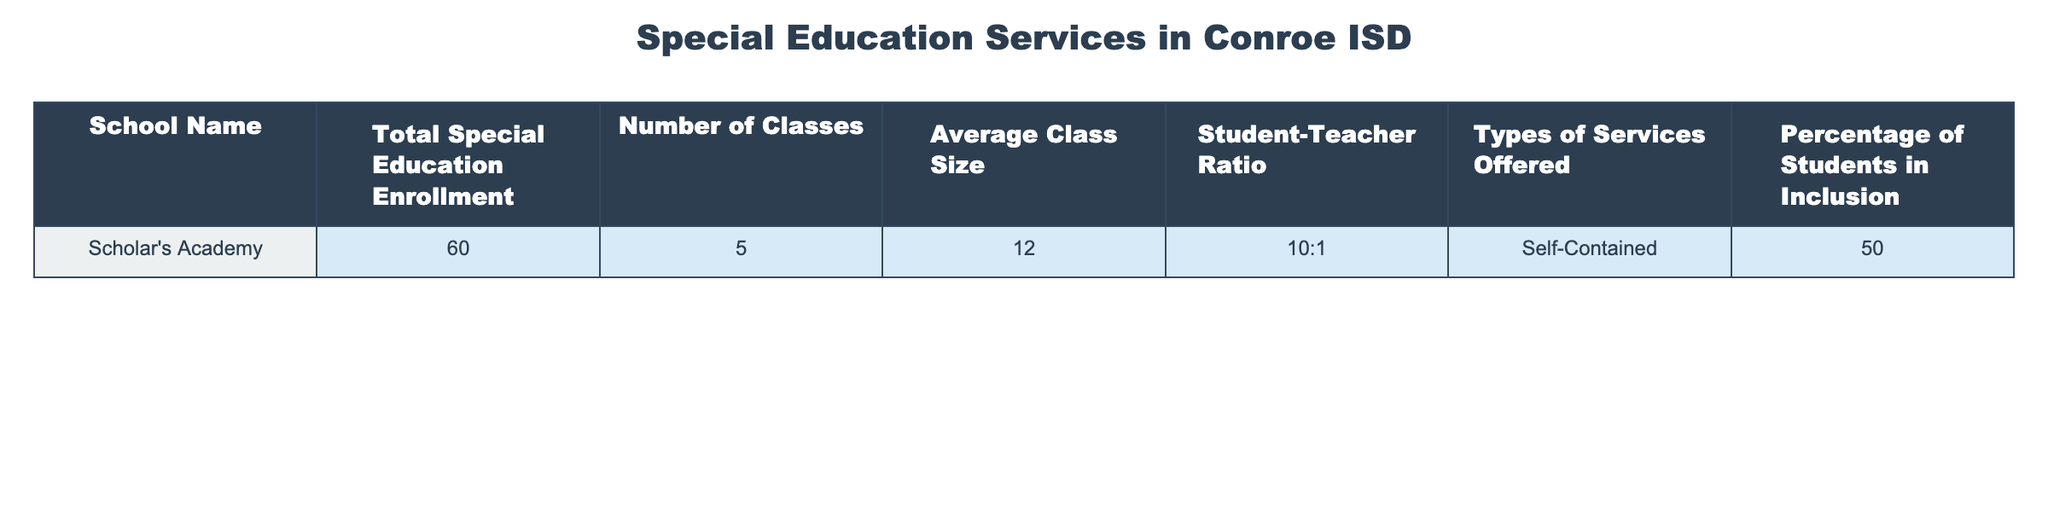What is the total special education enrollment at Scholar's Academy? The table directly provides the total special education enrollment figure for Scholar's Academy, which is 60.
Answer: 60 How many classes are offered for special education at Scholar's Academy? The table lists the number of classes for Scholar's Academy as 5.
Answer: 5 What is the average class size in Scholar's Academy's special education? According to the table, the average class size for Scholar's Academy is 12 students per class.
Answer: 12 Is the student-teacher ratio at Scholar's Academy 10:1? The table shows the student-teacher ratio for Scholar's Academy is 10:1, which confirms the statement is true.
Answer: Yes What percentage of students at Scholar's Academy are in inclusion? The table indicates that 50% of the students at Scholar's Academy are in inclusion.
Answer: 50% If you wanted to find the total number of students across all classes at Scholar's Academy, what would that be? To find the total number of students, multiply the average class size (12) by the number of classes (5). Therefore, 12 * 5 = 60. This matches the total special education enrollment.
Answer: 60 How many more students are in the inclusion program compared to non-inclusion at Scholar's Academy? To determine this, we first need to find the number of students in inclusion. Since 50% are in inclusion, that is 30 students (50% of 60). This implies that the remaining 30 students are in non-inclusion. Therefore, the difference is 30 - 30 = 0.
Answer: 0 Is it true that the average class size is greater than the number of classes at Scholar's Academy? The average class size is 12, and the number of classes is 5. Since 12 is greater than 5, this statement is indeed true.
Answer: Yes What is the total special education student capacity implied if the average class size remains constant and all classes reach maximum capacity? To find the maximum capacity, multiply the average class size (12) by the number of classes (5), which equals 60. This implies that the total capacity is the same as the current enrollment of 60.
Answer: 60 